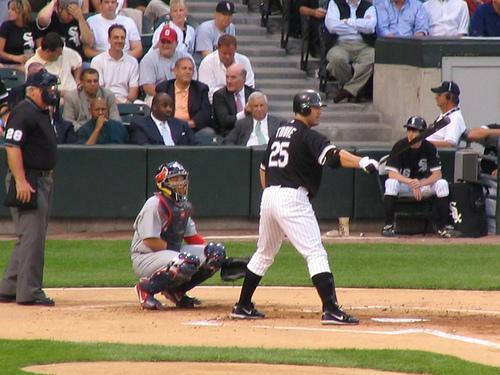How many people are wearing baseball hats?
Give a very brief answer. 4. How many people are there?
Give a very brief answer. 7. 